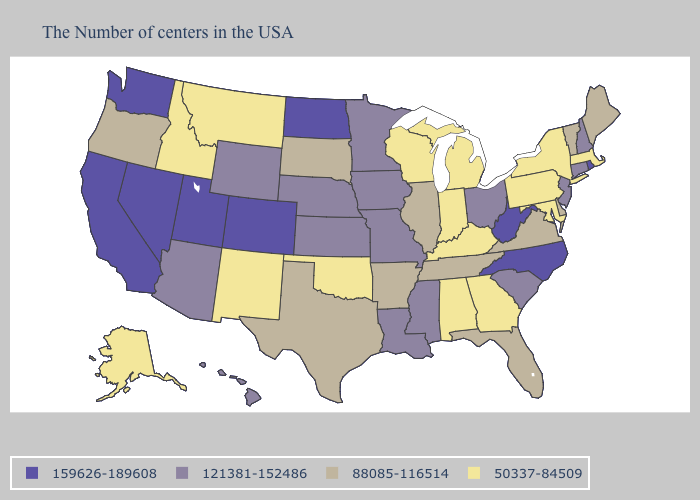What is the lowest value in the South?
Quick response, please. 50337-84509. Does Indiana have the lowest value in the USA?
Answer briefly. Yes. Which states have the highest value in the USA?
Concise answer only. Rhode Island, North Carolina, West Virginia, North Dakota, Colorado, Utah, Nevada, California, Washington. What is the value of South Dakota?
Concise answer only. 88085-116514. Among the states that border Maryland , does Virginia have the lowest value?
Concise answer only. No. Among the states that border Texas , does Oklahoma have the highest value?
Concise answer only. No. What is the highest value in states that border Montana?
Answer briefly. 159626-189608. Name the states that have a value in the range 88085-116514?
Answer briefly. Maine, Vermont, Delaware, Virginia, Florida, Tennessee, Illinois, Arkansas, Texas, South Dakota, Oregon. What is the value of Nebraska?
Keep it brief. 121381-152486. Does Idaho have the highest value in the West?
Keep it brief. No. Name the states that have a value in the range 88085-116514?
Short answer required. Maine, Vermont, Delaware, Virginia, Florida, Tennessee, Illinois, Arkansas, Texas, South Dakota, Oregon. What is the value of New Mexico?
Quick response, please. 50337-84509. Name the states that have a value in the range 88085-116514?
Quick response, please. Maine, Vermont, Delaware, Virginia, Florida, Tennessee, Illinois, Arkansas, Texas, South Dakota, Oregon. Name the states that have a value in the range 88085-116514?
Quick response, please. Maine, Vermont, Delaware, Virginia, Florida, Tennessee, Illinois, Arkansas, Texas, South Dakota, Oregon. 